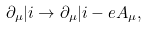<formula> <loc_0><loc_0><loc_500><loc_500>\partial _ { \mu } | i \rightarrow \partial _ { \mu } | i - e A _ { \mu } ,</formula> 